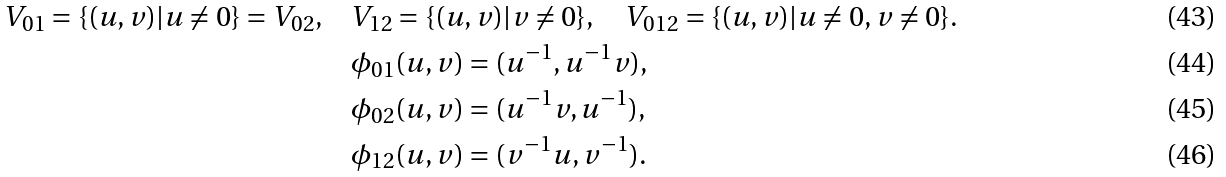<formula> <loc_0><loc_0><loc_500><loc_500>V _ { 0 1 } = \{ ( u , v ) | u \not = 0 \} = V _ { 0 2 } , \quad & V _ { 1 2 } = \{ ( u , v ) | v \not = 0 \} , \quad V _ { 0 1 2 } = \{ ( u , v ) | u \not = 0 , v \not = 0 \} . \\ & \phi _ { 0 1 } ( u , v ) = ( u ^ { - 1 } , u ^ { - 1 } v ) , \\ & \phi _ { 0 2 } ( u , v ) = ( u ^ { - 1 } v , u ^ { - 1 } ) , \\ & \phi _ { 1 2 } ( u , v ) = ( v ^ { - 1 } u , v ^ { - 1 } ) .</formula> 